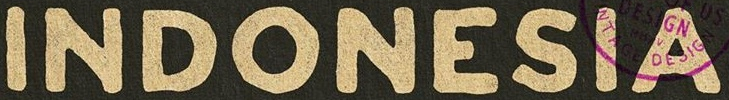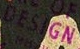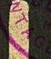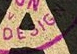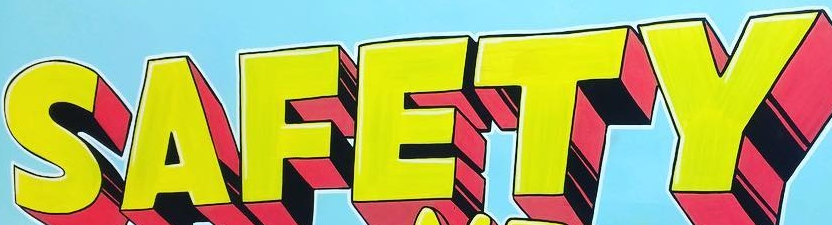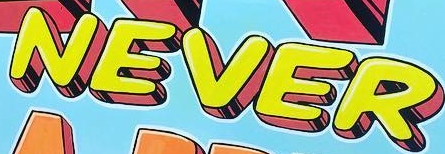What text appears in these images from left to right, separated by a semicolon? INDONESIA; DESIGN; NTAG; DESIGN; SAFETY; NEVER 